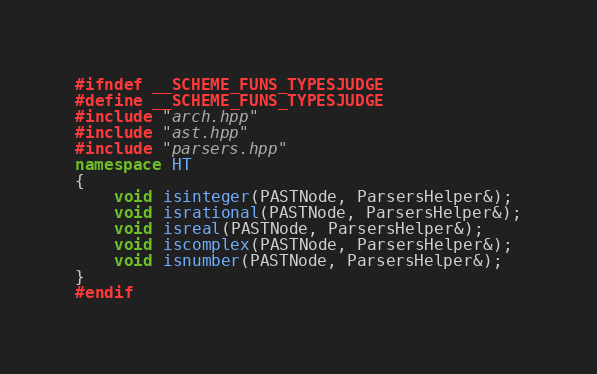Convert code to text. <code><loc_0><loc_0><loc_500><loc_500><_C++_>#ifndef __SCHEME_FUNS_TYPESJUDGE
#define __SCHEME_FUNS_TYPESJUDGE
#include "arch.hpp"
#include "ast.hpp"
#include "parsers.hpp"
namespace HT
{
    void isinteger(PASTNode, ParsersHelper&);
    void isrational(PASTNode, ParsersHelper&);
    void isreal(PASTNode, ParsersHelper&);
    void iscomplex(PASTNode, ParsersHelper&);
    void isnumber(PASTNode, ParsersHelper&);
}
#endif
</code> 